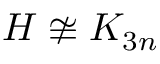Convert formula to latex. <formula><loc_0><loc_0><loc_500><loc_500>H \not \cong K _ { 3 n }</formula> 